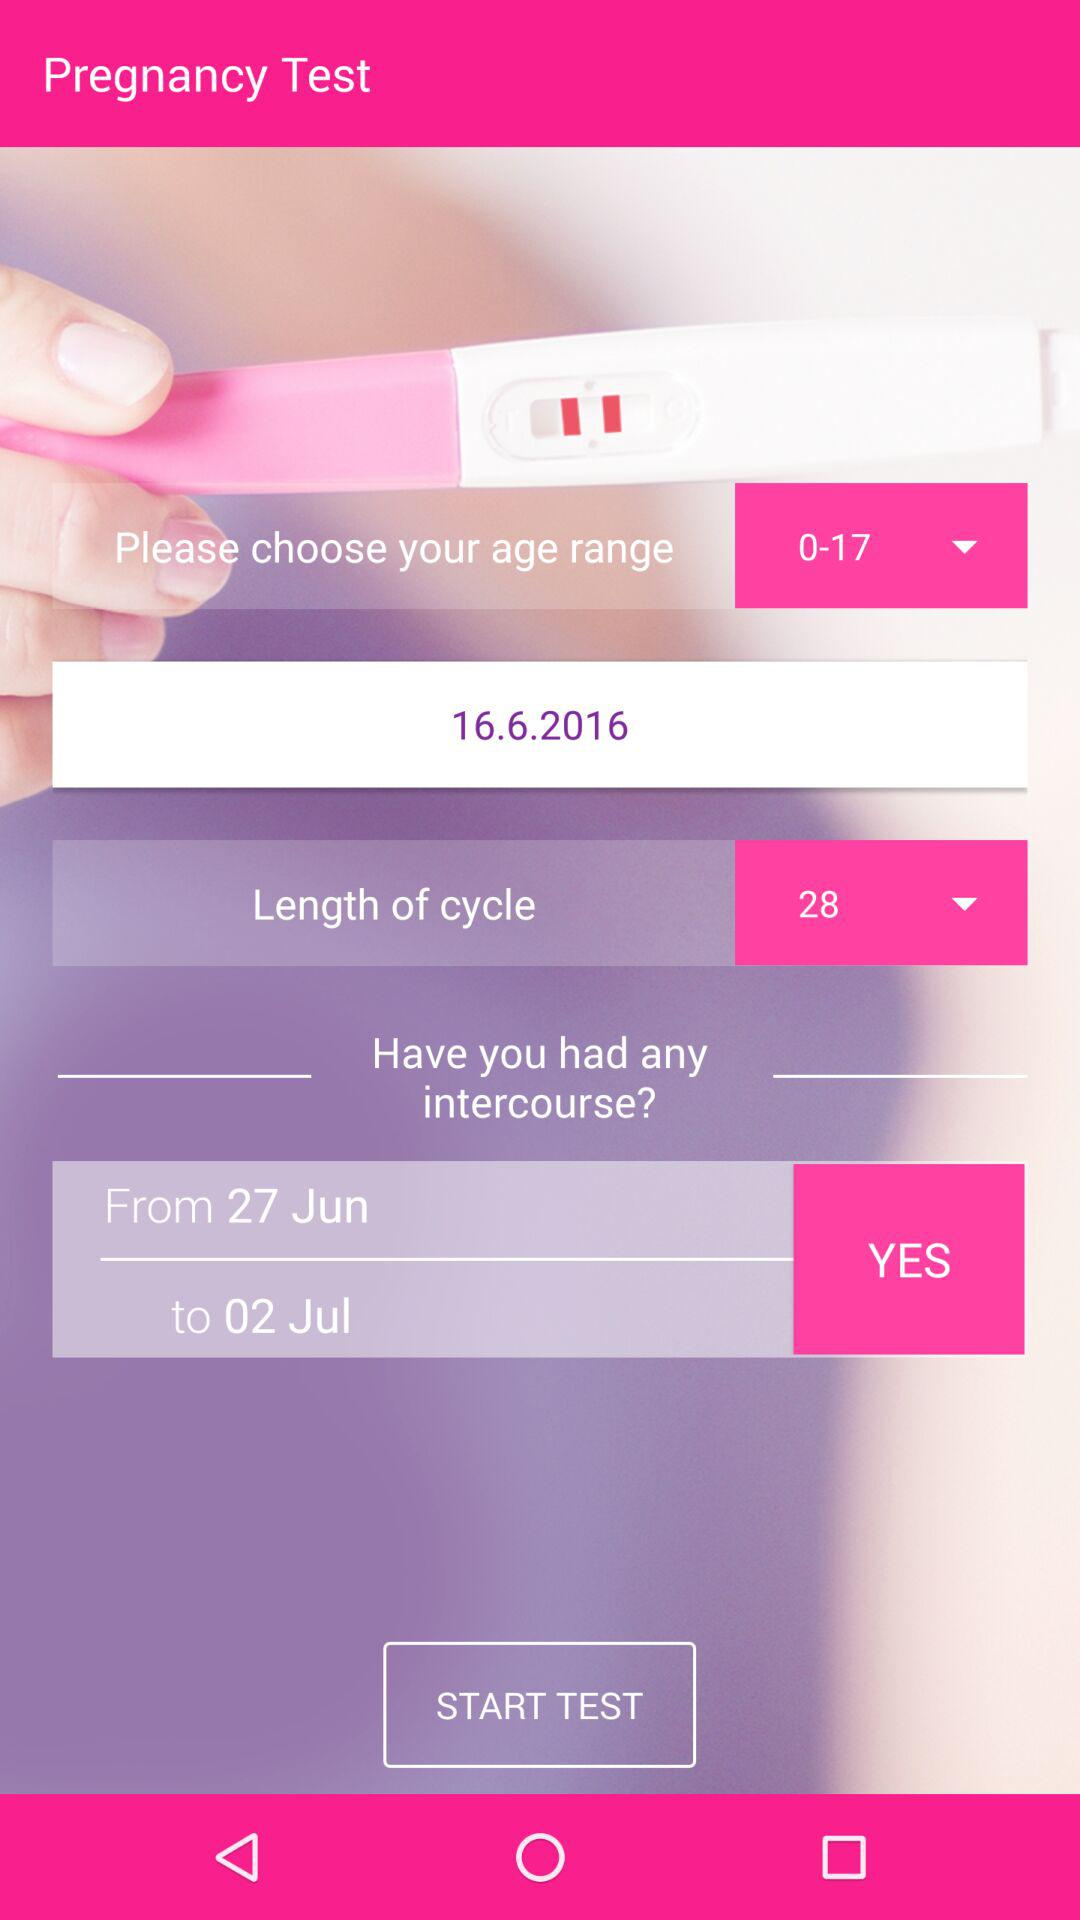What is the date range for "Have you had any intercourse?"? The date range for "Have you had any intercourse?" is from June 27 to July 2. 